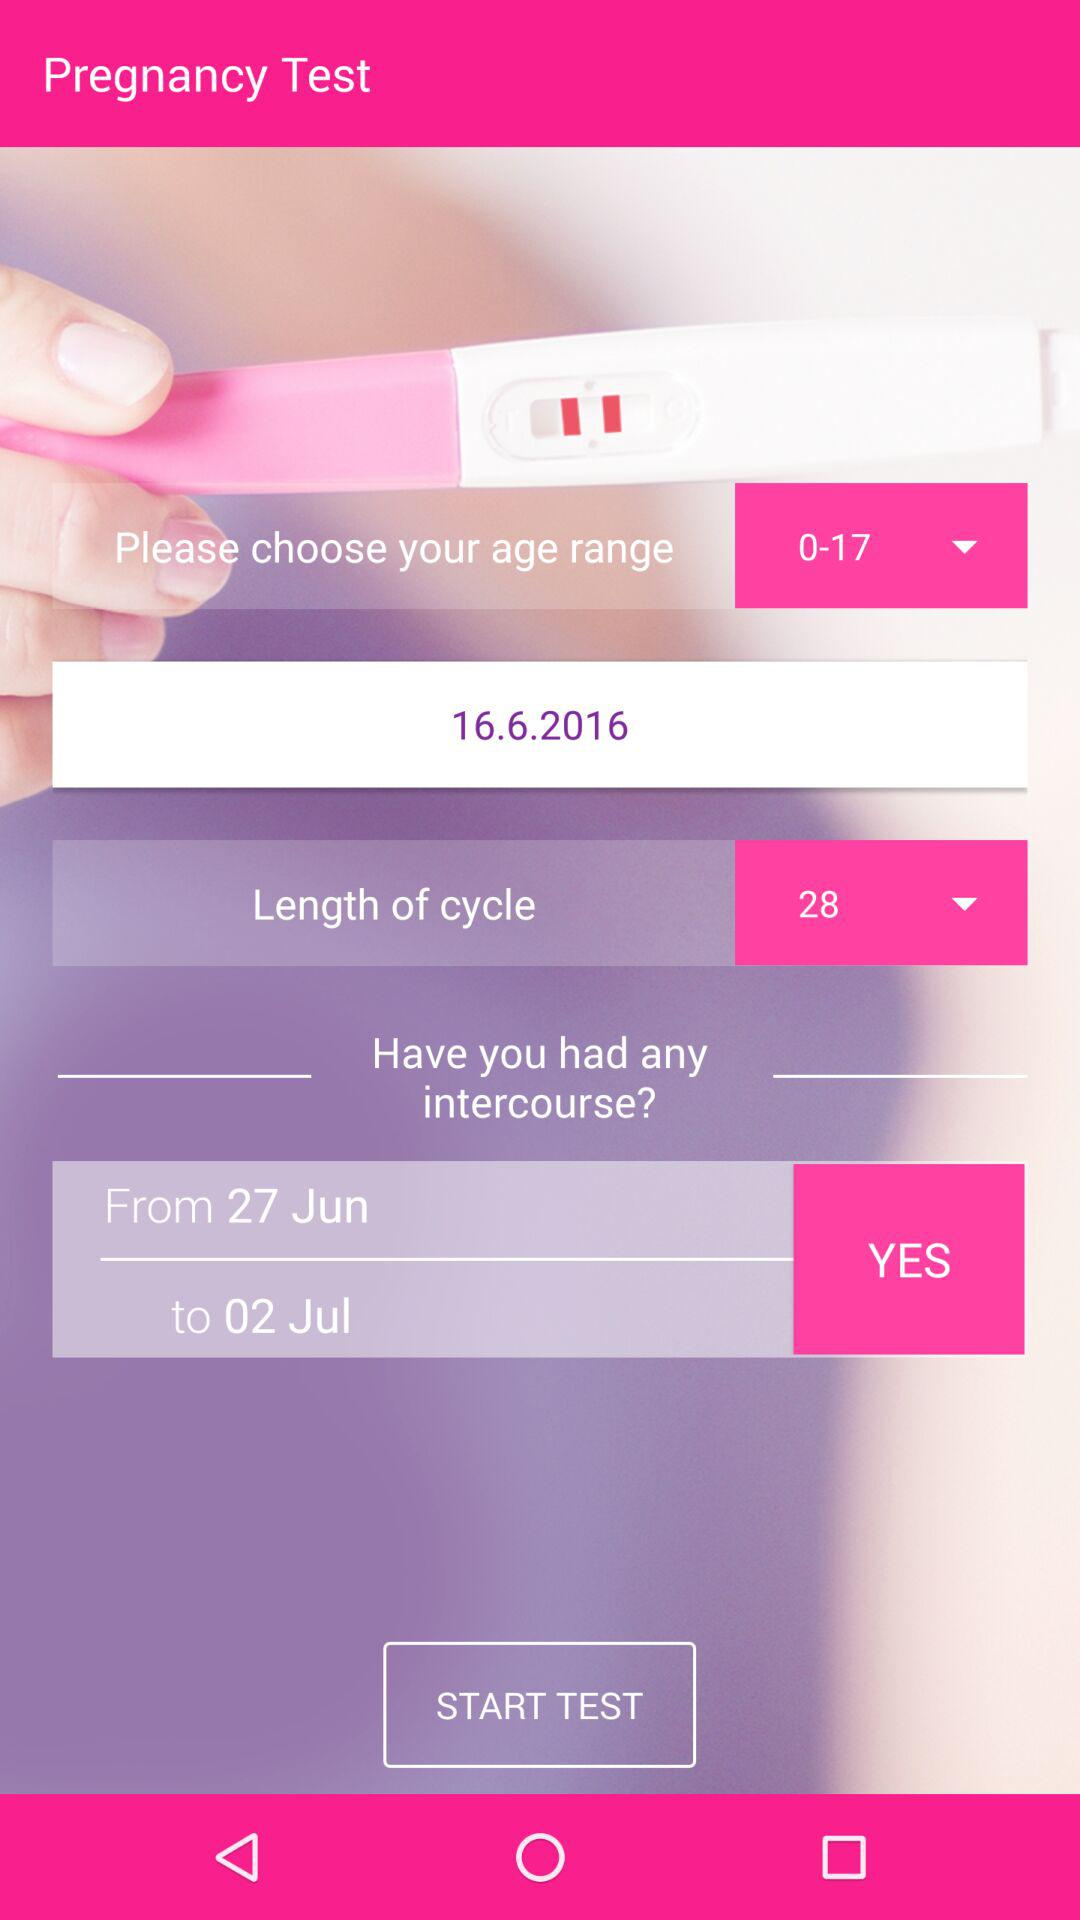What is the date range for "Have you had any intercourse?"? The date range for "Have you had any intercourse?" is from June 27 to July 2. 